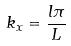Convert formula to latex. <formula><loc_0><loc_0><loc_500><loc_500>k _ { x } = \frac { l \pi } { L }</formula> 